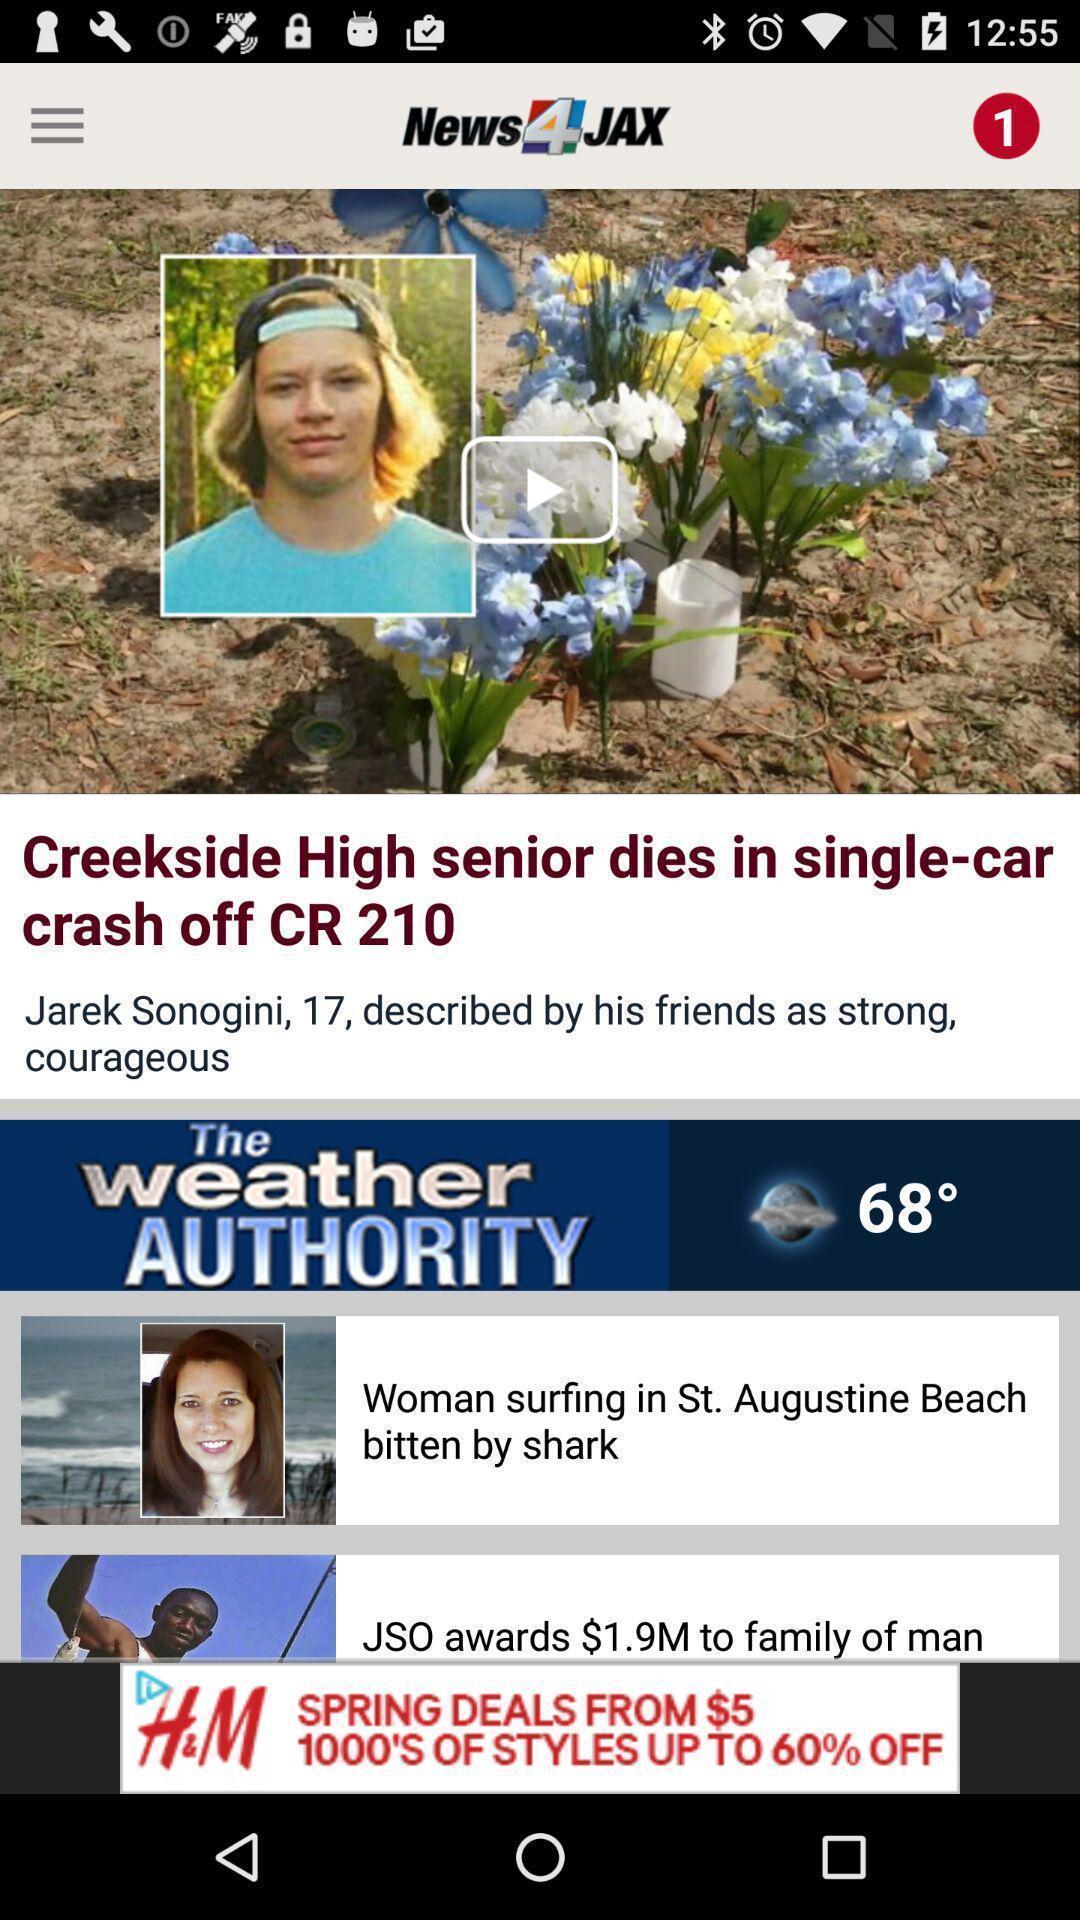Give me a narrative description of this picture. Posts feed page in a news app. 